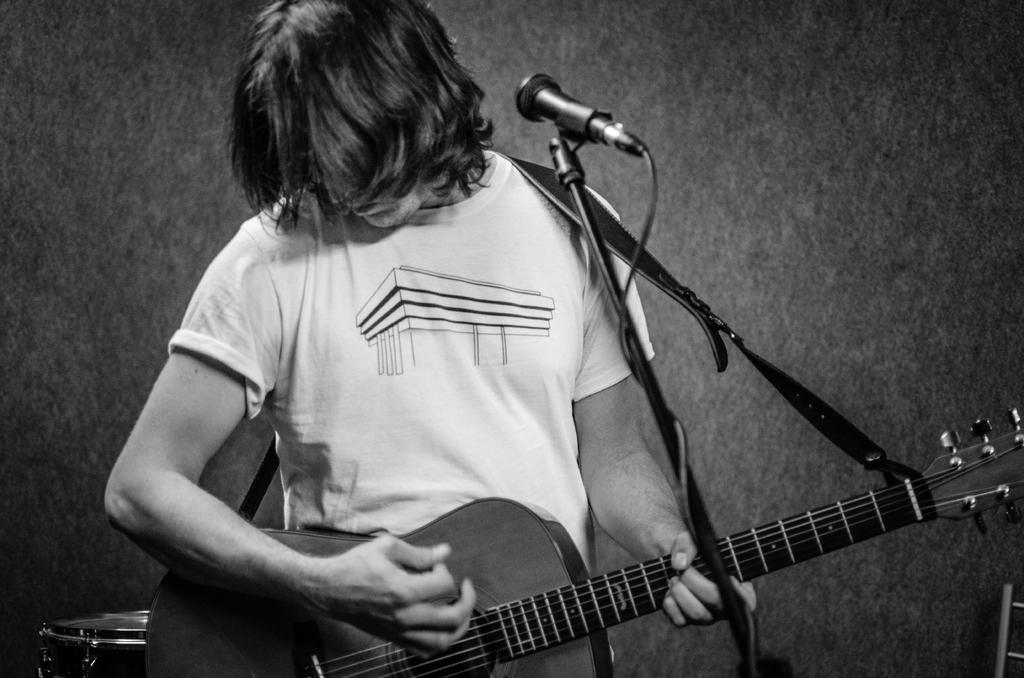What is the color scheme of the image? The image is black and white. Who is present in the image? There is a man in the image. Can you describe the man's appearance? The man has short hair. What is the man doing in the image? The man is standing in front of a microphone and playing a guitar. What type of quill is the man using to write on the gate in the image? There is no quill or gate present in the image. The man is playing a guitar and standing in front of a microphone. 